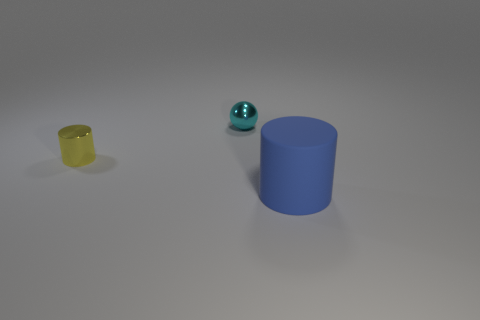Is there any other thing that is the same size as the blue thing?
Your answer should be compact. No. Is there anything else that has the same material as the blue cylinder?
Offer a terse response. No. Is the number of objects in front of the yellow metal cylinder less than the number of things that are in front of the sphere?
Ensure brevity in your answer.  Yes. The cyan thing is what shape?
Make the answer very short. Sphere. What color is the other small thing that is the same material as the cyan object?
Keep it short and to the point. Yellow. Are there more tiny things than objects?
Your answer should be very brief. No. Is there a yellow shiny cylinder?
Your answer should be very brief. Yes. There is a object that is behind the cylinder that is behind the big blue cylinder; what is its shape?
Your answer should be compact. Sphere. How many things are either cyan spheres or small shiny objects right of the tiny yellow metal cylinder?
Offer a very short reply. 1. What is the color of the tiny thing behind the cylinder that is to the left of the object that is to the right of the sphere?
Your response must be concise. Cyan. 